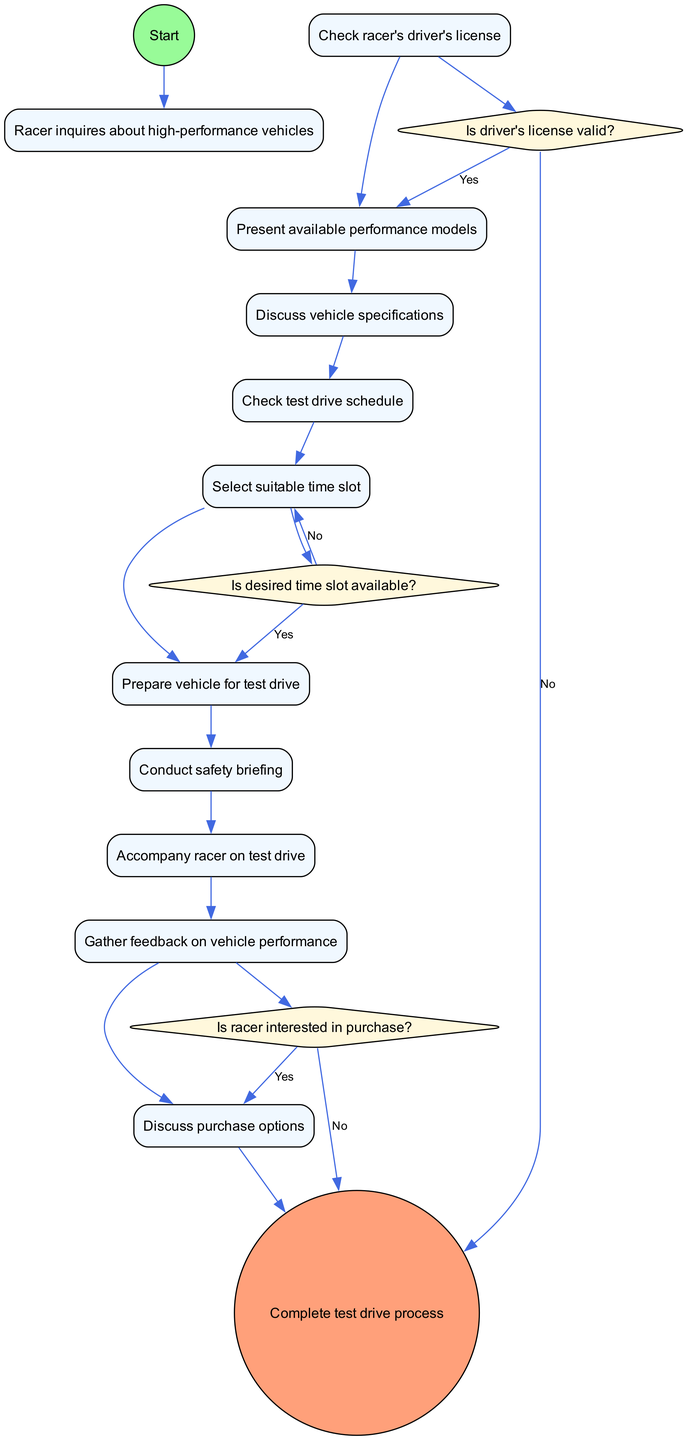What's the first activity in the process? The first activity is indicated directly after the start node. It states "Check racer's driver's license" as the first action to take after a racer inquires about high-performance vehicles.
Answer: Check racer's driver's license How many activities are listed in the diagram? The diagram lists a total of 10 activities that outline steps taken during the test drive scheduling and conducting process.
Answer: 10 What decision follows the check of the driver's license? The decision that follows is whether the driver's license is valid or not. If valid, it leads to the activity "Present available performance models."
Answer: Is driver's license valid? What happens if the desired time slot is not available? If the desired time slot is not available, the process directs to "Select suitable time slot" to find an alternative time for the test drive.
Answer: Select suitable time slot Which activity comes immediately before gathering feedback on vehicle performance? The activity immediately before gathering feedback is "Accompany racer on test drive," which involves taking the racer for a drive before asking for their opinions.
Answer: Accompany racer on test drive What is the outcome if the racer's license is invalid? The outcome indicated is that the process ends immediately without further actions, signifying a halt in scheduling or conducting the test drive.
Answer: End process How many decision points are present in the diagram? The diagram includes 3 decision points that guide the flow based on specific conditions regarding the license validity, time slot availability, and interest in purchase options.
Answer: 3 What activity is conducted after the safety briefing? After conducting the safety briefing, the next activity is to "Accompany racer on test drive," where the racer is taken for their performance vehicle test drive.
Answer: Accompany racer on test drive What is discussed at the end of the test drive process? At the end of the test drive process, the activities involve "Discuss purchase options" if the racer shows interest in buying the vehicle based on their experience.
Answer: Discuss purchase options 